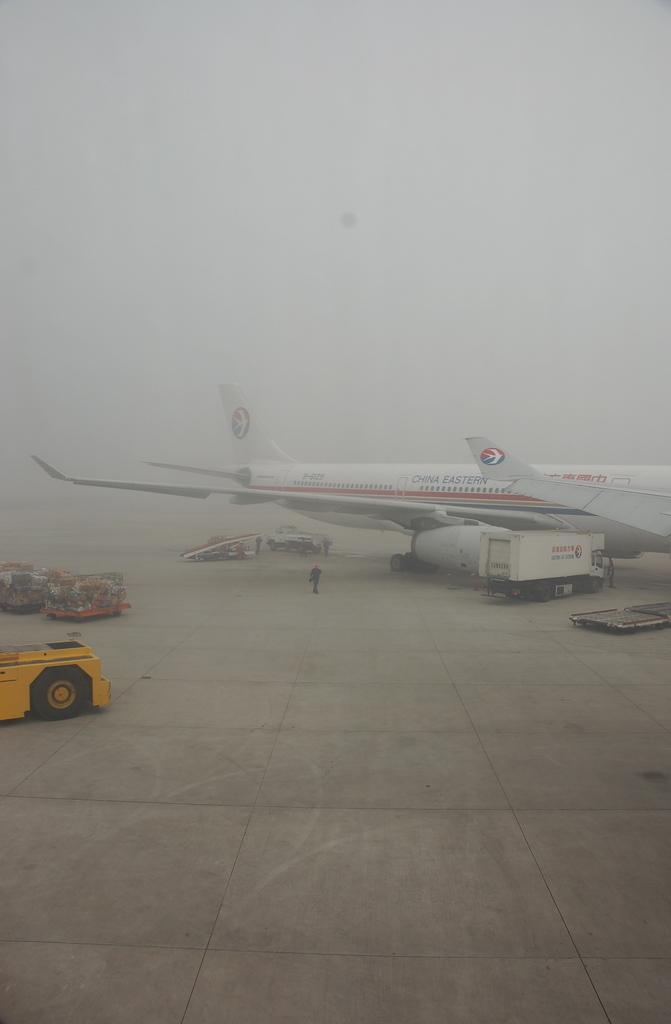What is the main subject of the image? The main subject of the image is an airplane. What else can be seen in the image besides the airplane? There are vehicles on a runway in the image. What is the income of the airplane in the image? There is no information about the income of the airplane in the image, as it is not relevant to the image's content. 